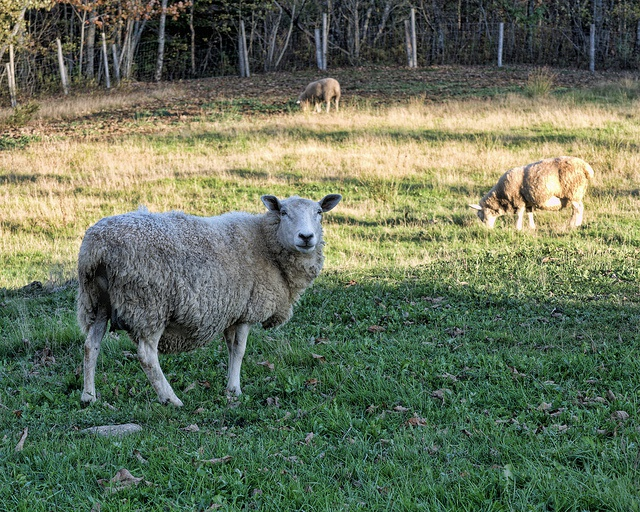Describe the objects in this image and their specific colors. I can see sheep in tan, gray, darkgray, and black tones, sheep in tan and ivory tones, and sheep in tan, gray, and black tones in this image. 